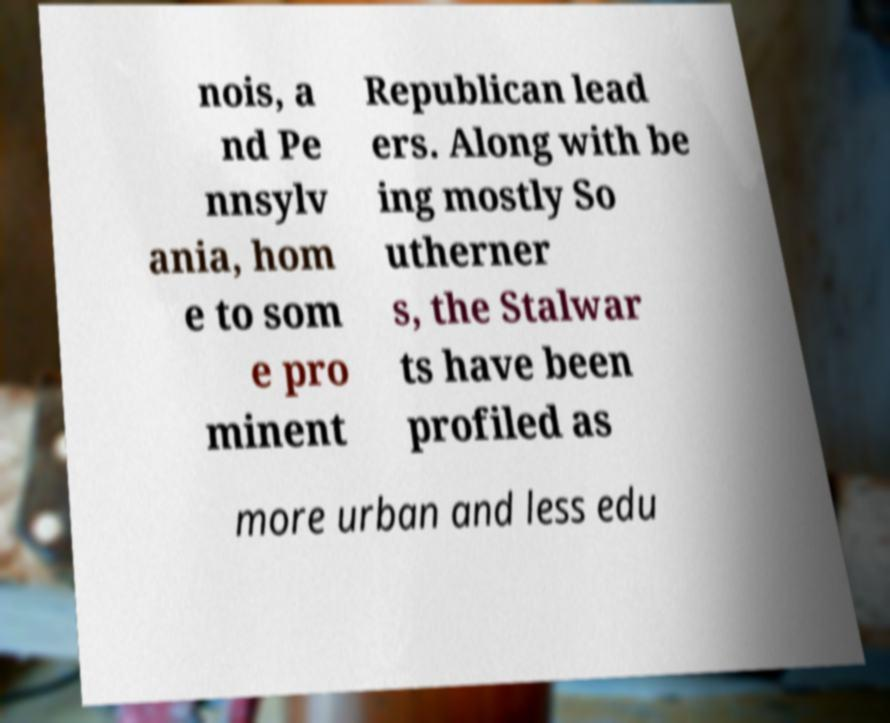Could you extract and type out the text from this image? nois, a nd Pe nnsylv ania, hom e to som e pro minent Republican lead ers. Along with be ing mostly So utherner s, the Stalwar ts have been profiled as more urban and less edu 